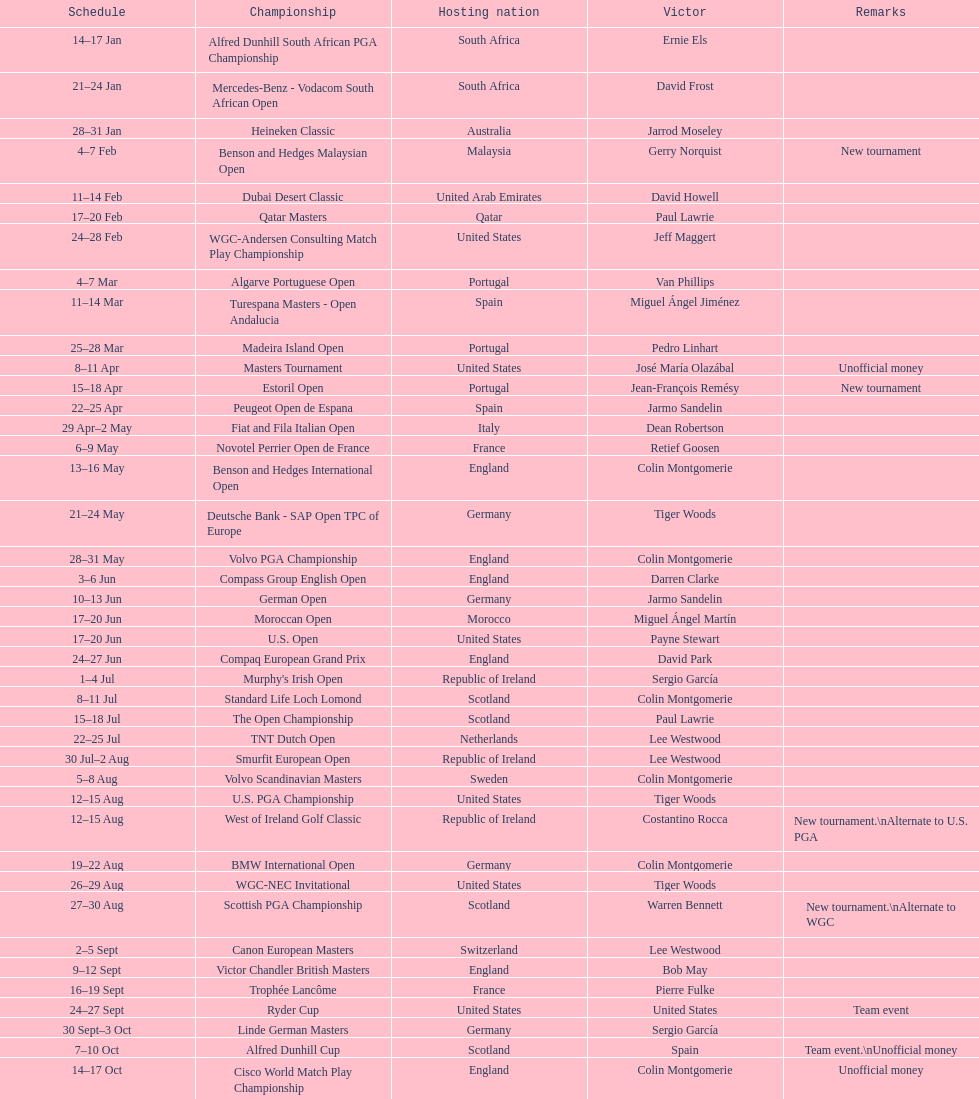Does any country have more than 5 winners? Yes. 